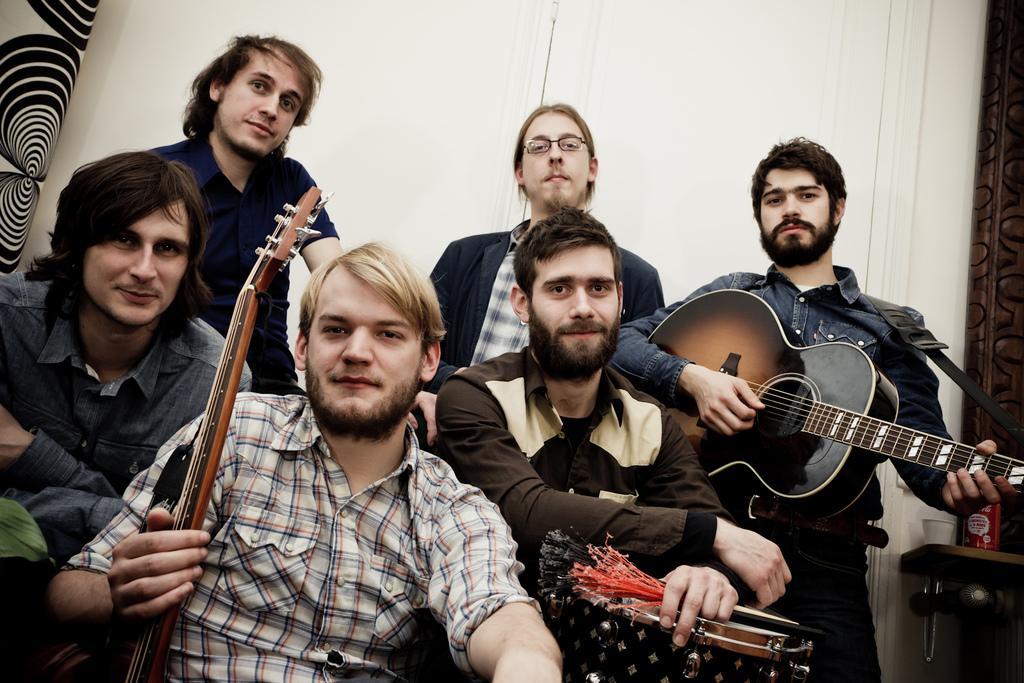Describe this image in one or two sentences. There is a group of men in this given picture. One guy in the right is holding a guitar, another guy is holding drums. In the background there is a wall and a door here. 